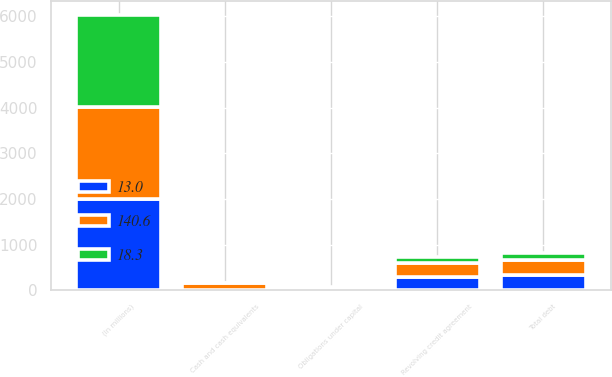<chart> <loc_0><loc_0><loc_500><loc_500><stacked_bar_chart><ecel><fcel>(In millions)<fcel>Revolving credit agreement<fcel>Obligations under capital<fcel>Total debt<fcel>Cash and cash equivalents<nl><fcel>18.3<fcel>2010<fcel>122.5<fcel>28.1<fcel>150.6<fcel>18.3<nl><fcel>140.6<fcel>2009<fcel>308.5<fcel>28.6<fcel>337<fcel>140.6<nl><fcel>13<fcel>2008<fcel>300.2<fcel>27.6<fcel>327.8<fcel>13<nl></chart> 